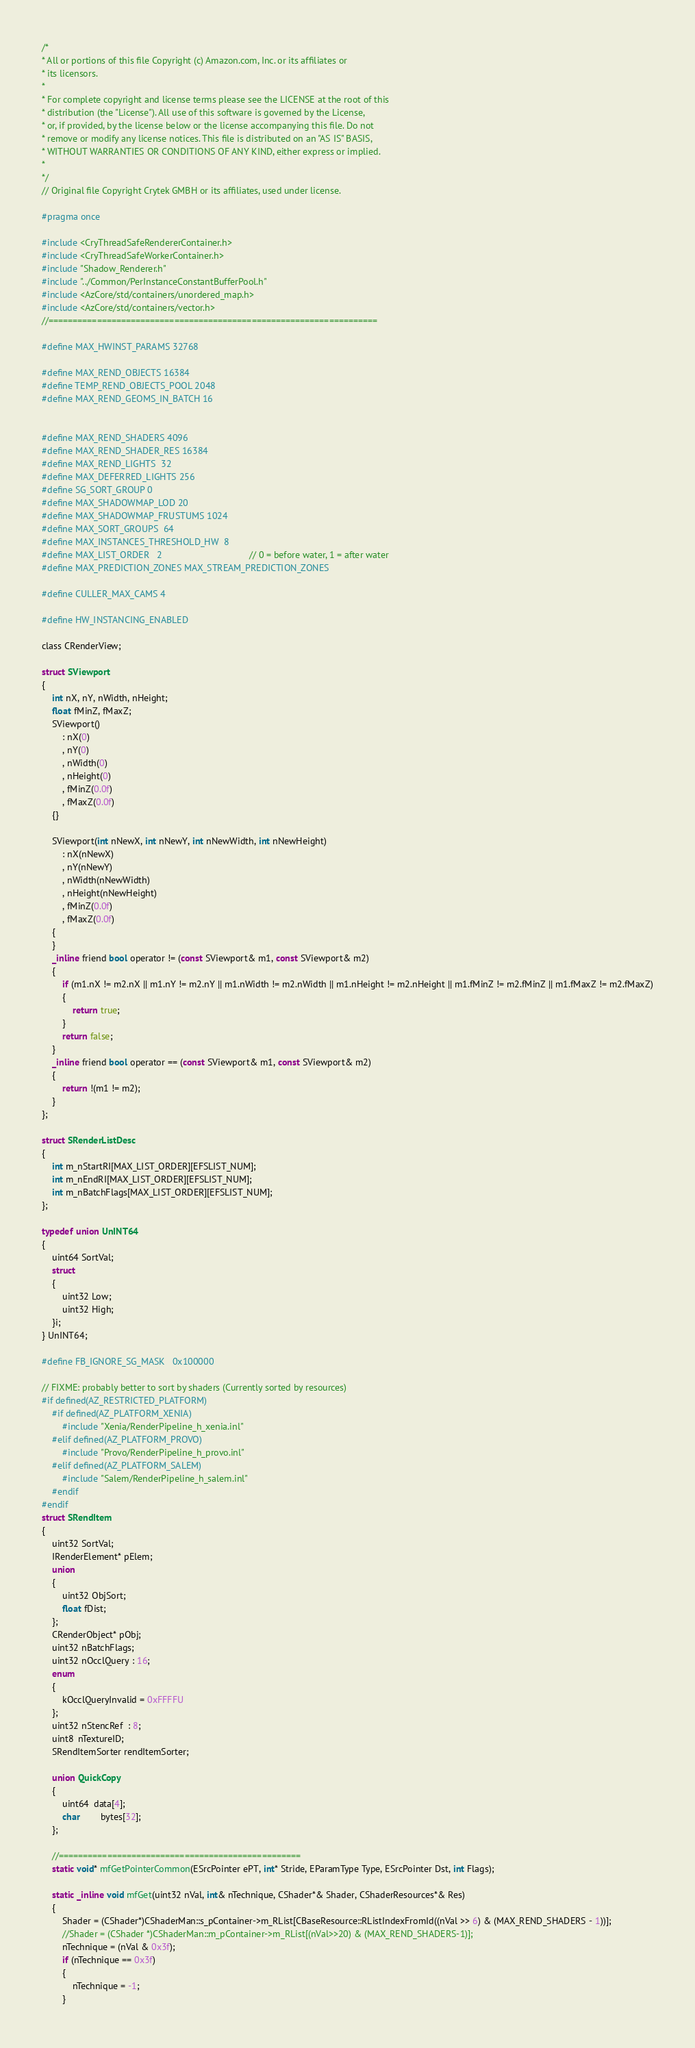<code> <loc_0><loc_0><loc_500><loc_500><_C_>/*
* All or portions of this file Copyright (c) Amazon.com, Inc. or its affiliates or
* its licensors.
*
* For complete copyright and license terms please see the LICENSE at the root of this
* distribution (the "License"). All use of this software is governed by the License,
* or, if provided, by the license below or the license accompanying this file. Do not
* remove or modify any license notices. This file is distributed on an "AS IS" BASIS,
* WITHOUT WARRANTIES OR CONDITIONS OF ANY KIND, either express or implied.
*
*/
// Original file Copyright Crytek GMBH or its affiliates, used under license.

#pragma once

#include <CryThreadSafeRendererContainer.h>
#include <CryThreadSafeWorkerContainer.h>
#include "Shadow_Renderer.h"
#include "../Common/PerInstanceConstantBufferPool.h"
#include <AzCore/std/containers/unordered_map.h>
#include <AzCore/std/containers/vector.h>
//====================================================================

#define MAX_HWINST_PARAMS 32768

#define MAX_REND_OBJECTS 16384
#define TEMP_REND_OBJECTS_POOL 2048
#define MAX_REND_GEOMS_IN_BATCH 16


#define MAX_REND_SHADERS 4096
#define MAX_REND_SHADER_RES 16384
#define MAX_REND_LIGHTS  32
#define MAX_DEFERRED_LIGHTS 256
#define SG_SORT_GROUP 0
#define MAX_SHADOWMAP_LOD 20
#define MAX_SHADOWMAP_FRUSTUMS 1024
#define MAX_SORT_GROUPS  64
#define MAX_INSTANCES_THRESHOLD_HW  8
#define MAX_LIST_ORDER   2                                  // 0 = before water, 1 = after water
#define MAX_PREDICTION_ZONES MAX_STREAM_PREDICTION_ZONES

#define CULLER_MAX_CAMS 4

#define HW_INSTANCING_ENABLED

class CRenderView;

struct SViewport
{
    int nX, nY, nWidth, nHeight;
    float fMinZ, fMaxZ;
    SViewport()
        : nX(0)
        , nY(0)
        , nWidth(0)
        , nHeight(0)
        , fMinZ(0.0f)
        , fMaxZ(0.0f)
    {}

    SViewport(int nNewX, int nNewY, int nNewWidth, int nNewHeight)
        : nX(nNewX)
        , nY(nNewY)
        , nWidth(nNewWidth)
        , nHeight(nNewHeight)
        , fMinZ(0.0f)
        , fMaxZ(0.0f)
    {
    }
    _inline friend bool operator != (const SViewport& m1, const SViewport& m2)
    {
        if (m1.nX != m2.nX || m1.nY != m2.nY || m1.nWidth != m2.nWidth || m1.nHeight != m2.nHeight || m1.fMinZ != m2.fMinZ || m1.fMaxZ != m2.fMaxZ)
        {
            return true;
        }
        return false;
    }
    _inline friend bool operator == (const SViewport& m1, const SViewport& m2)
    {
        return !(m1 != m2);
    }
};

struct SRenderListDesc
{
    int m_nStartRI[MAX_LIST_ORDER][EFSLIST_NUM];
    int m_nEndRI[MAX_LIST_ORDER][EFSLIST_NUM];
    int m_nBatchFlags[MAX_LIST_ORDER][EFSLIST_NUM];
};

typedef union UnINT64
{
    uint64 SortVal;
    struct
    {
        uint32 Low;
        uint32 High;
    }i;
} UnINT64;

#define FB_IGNORE_SG_MASK   0x100000

// FIXME: probably better to sort by shaders (Currently sorted by resources)
#if defined(AZ_RESTRICTED_PLATFORM)
    #if defined(AZ_PLATFORM_XENIA)
        #include "Xenia/RenderPipeline_h_xenia.inl"
    #elif defined(AZ_PLATFORM_PROVO)
        #include "Provo/RenderPipeline_h_provo.inl"
    #elif defined(AZ_PLATFORM_SALEM)
        #include "Salem/RenderPipeline_h_salem.inl"
    #endif
#endif
struct SRendItem
{
    uint32 SortVal;
    IRenderElement* pElem;
    union
    {
        uint32 ObjSort;
        float fDist;
    };
    CRenderObject* pObj;
    uint32 nBatchFlags;
    uint32 nOcclQuery : 16;
    enum
    {
        kOcclQueryInvalid = 0xFFFFU
    };
    uint32 nStencRef  : 8;
    uint8  nTextureID;
    SRendItemSorter rendItemSorter;

    union QuickCopy
    {
        uint64  data[4];
        char        bytes[32];
    };

    //==================================================
    static void* mfGetPointerCommon(ESrcPointer ePT, int* Stride, EParamType Type, ESrcPointer Dst, int Flags);

    static _inline void mfGet(uint32 nVal, int& nTechnique, CShader*& Shader, CShaderResources*& Res)
    {
        Shader = (CShader*)CShaderMan::s_pContainer->m_RList[CBaseResource::RListIndexFromId((nVal >> 6) & (MAX_REND_SHADERS - 1))];
        //Shader = (CShader *)CShaderMan::m_pContainer->m_RList[(nVal>>20) & (MAX_REND_SHADERS-1)];
        nTechnique = (nVal & 0x3f);
        if (nTechnique == 0x3f)
        {
            nTechnique = -1;
        }</code> 